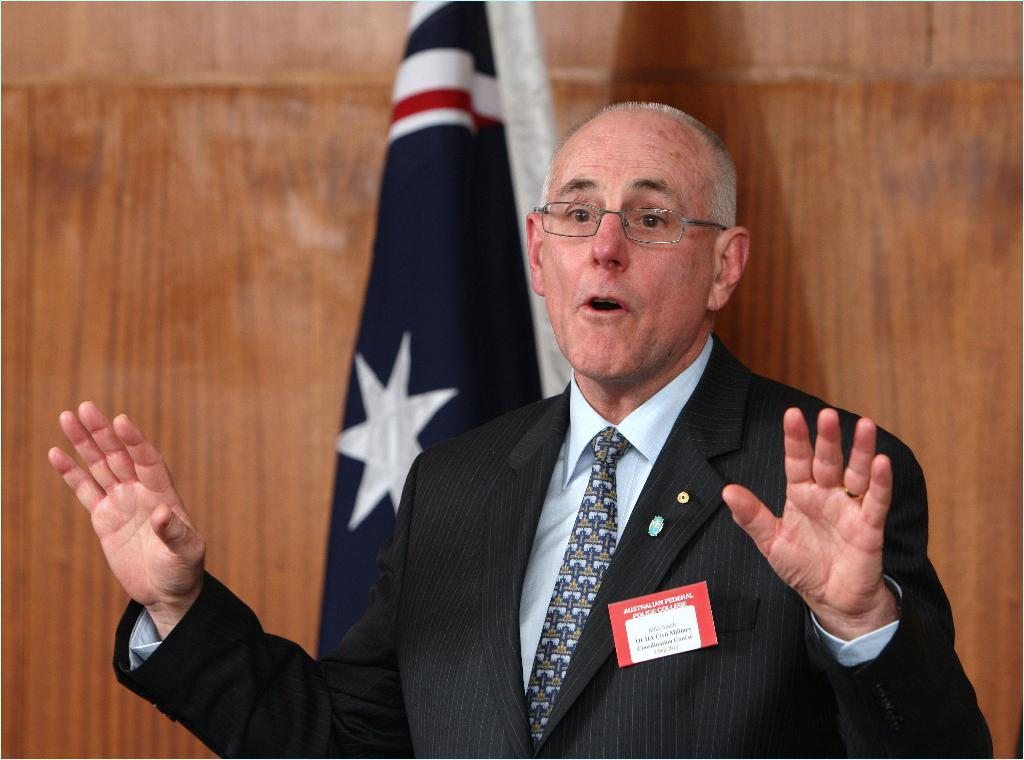What is the main subject of the image? There is a man standing in the image. What is the man wearing in the image? The man is wearing a blazer. What can be seen attached to a pole in the image? There is a flag attached to a pole in the image. What type of wall is visible in the backdrop of the image? There is a wooden wall in the backdrop of the image. How many bulbs are hanging from the wooden wall in the image? There are no bulbs visible in the image; only a man, a blazer, a flag, and a wooden wall are present. What type of ear is shown on the man's face in the image? The man's ears are not visible in the image, so it cannot be determined what type of ear is shown. 